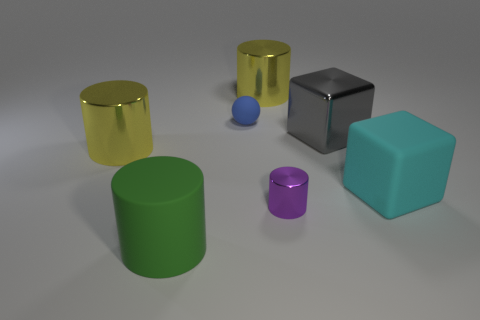Subtract all gray cubes. Subtract all brown cylinders. How many cubes are left? 1 Add 2 yellow shiny cubes. How many objects exist? 9 Subtract all cylinders. How many objects are left? 3 Subtract 1 purple cylinders. How many objects are left? 6 Subtract all tiny brown rubber balls. Subtract all tiny matte things. How many objects are left? 6 Add 4 small cylinders. How many small cylinders are left? 5 Add 1 small purple metal objects. How many small purple metal objects exist? 2 